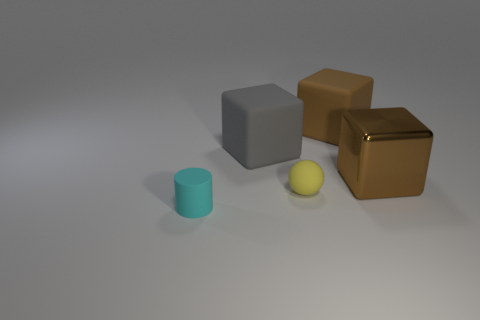What number of things are either things on the right side of the gray block or metal things?
Your answer should be very brief. 3. Is the material of the tiny cyan cylinder the same as the yellow thing?
Offer a very short reply. Yes. The other brown object that is the same shape as the shiny thing is what size?
Make the answer very short. Large. There is a matte object to the right of the yellow object; is it the same shape as the thing in front of the matte sphere?
Provide a short and direct response. No. There is a gray block; does it have the same size as the brown cube that is left of the metallic object?
Make the answer very short. Yes. Is there anything else that is the same shape as the big gray object?
Offer a terse response. Yes. There is a rubber block that is in front of the big thing behind the gray object that is behind the small yellow ball; what is its color?
Keep it short and to the point. Gray. What is the shape of the rubber thing that is both behind the tiny yellow ball and on the right side of the big gray rubber thing?
Offer a very short reply. Cube. Is there any other thing that is the same size as the brown shiny block?
Give a very brief answer. Yes. There is a rubber block that is on the right side of the rubber block that is on the left side of the tiny sphere; what is its color?
Provide a short and direct response. Brown. 